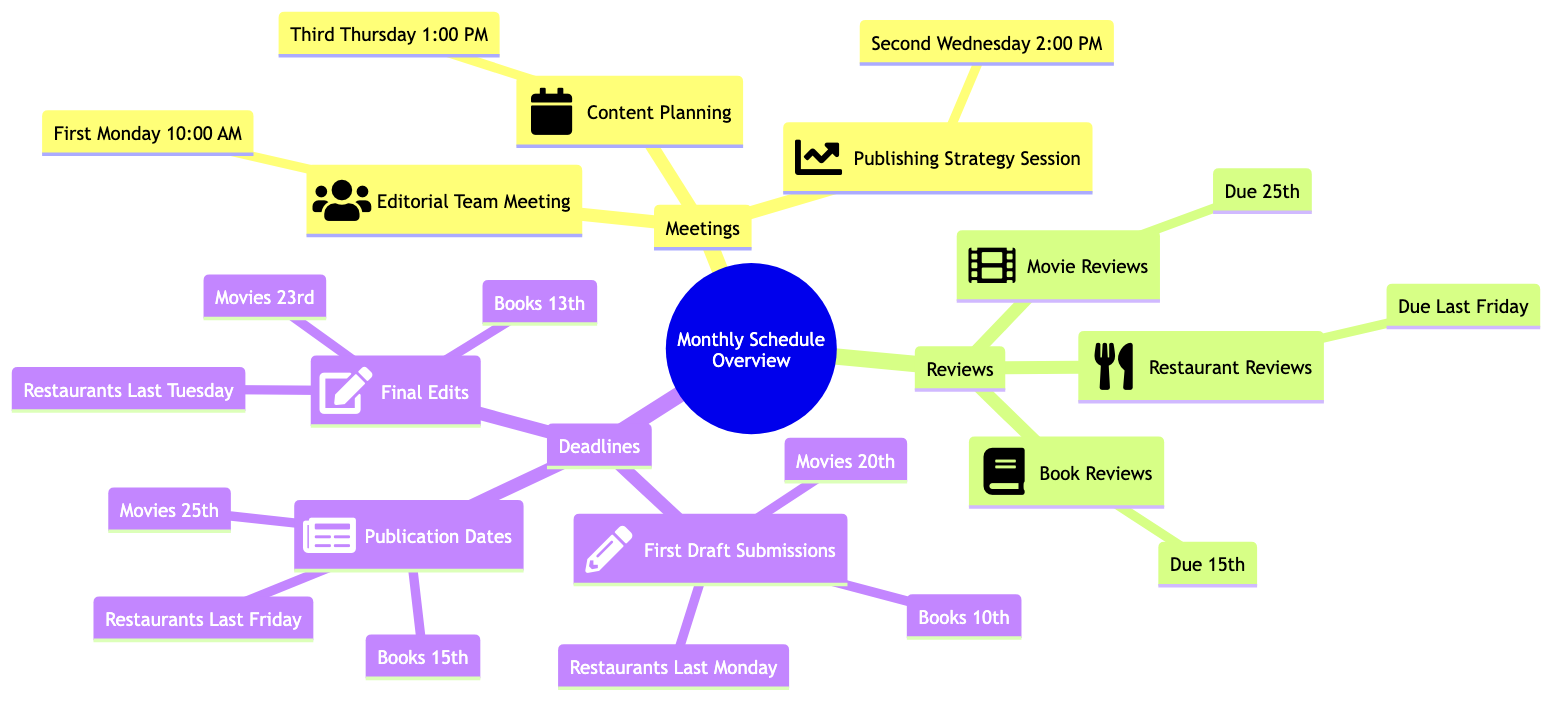What is the time for the Editorial Team Meeting? The diagram specifies that the Editorial Team Meeting occurs at 10:00 AM to 11:00 AM on the first Monday of the month. Thus, the time for the meeting is directly quoted from this information.
Answer: 10:00 AM - 11:00 AM How many meetings are listed in the diagram? The diagram contains three distinct meetings: Editorial Team Meeting, Publishing Strategy Session, and Content Planning. By counting these entries, we arrive at the total number of meetings.
Answer: 3 What is the due date for Book Reviews? The diagram states that Book Reviews are due on the 15th of the month. This specific due date is referenced directly within the Reviews section, highlighting its importance.
Answer: 15th Which meeting occurs on the second Wednesday of the Month? The Publishing Strategy Session is indicated as taking place on the second Wednesday of the month. This information is clearly outlined under the Meetings section of the diagram.
Answer: Publishing Strategy Session How many different types of reviews are scheduled? There are three types of reviews mentioned in the diagram: Book Reviews, Movie Reviews, and Restaurant Reviews. This count is derived from examining the Reviews section and summarizing the entries there.
Answer: 3 What is the final edits due date for Movie Reviews? According to the diagram, final edits for Movie Reviews are due on the 23rd of the month. This due date is directly detailed in the Deadlines section of the diagram, specifically under final edits.
Answer: 23rd What is the last deadline of the month for Restaurant Reviews? The last Monday of the month is specified for the first draft submissions of Restaurant Reviews. This deadline is found in the Deadlines section and is the latest mentioned for this category.
Answer: Last Monday What is the publication date for Movie Reviews? The publication date for Movie Reviews is specified as the 25th of the Month in the Deadlines section. This information indicates when these reviews will be made public.
Answer: 25th 